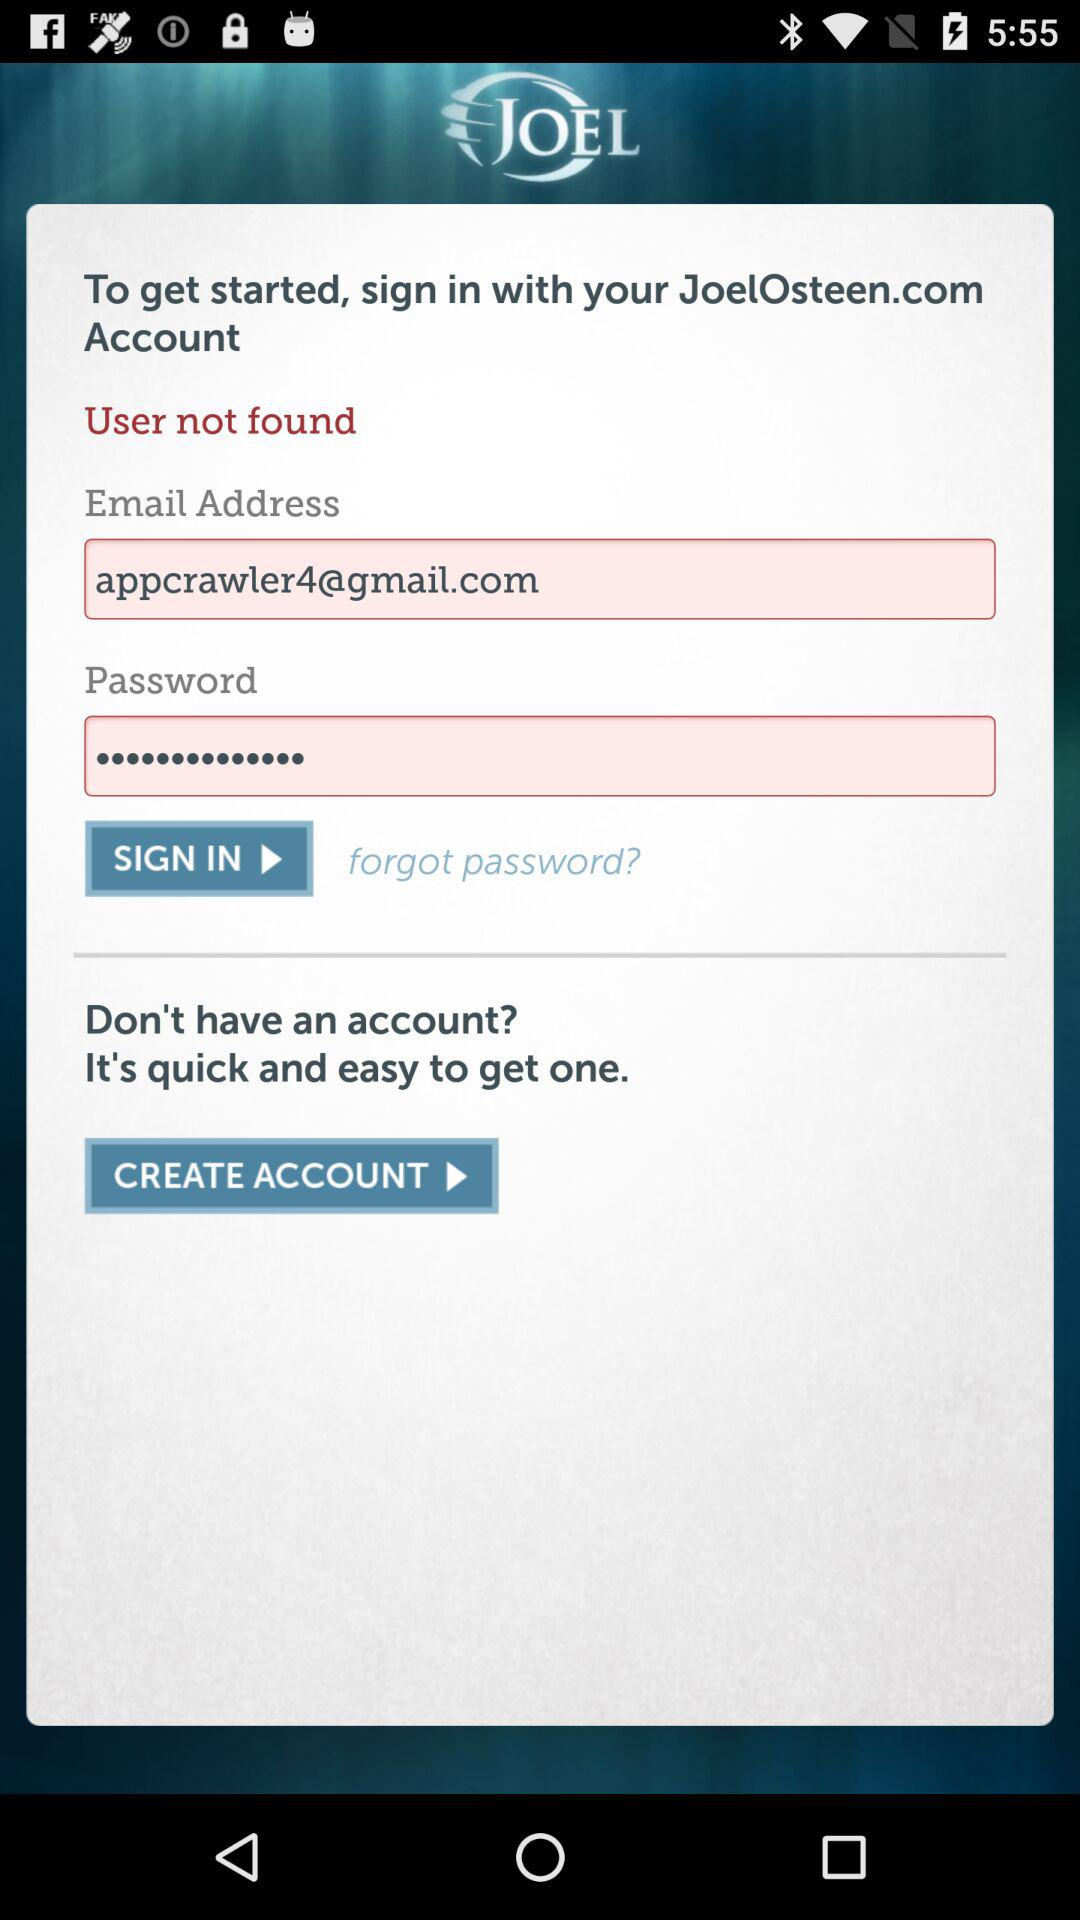What is the name of the application? The name of the application is "JoelOsteen". 